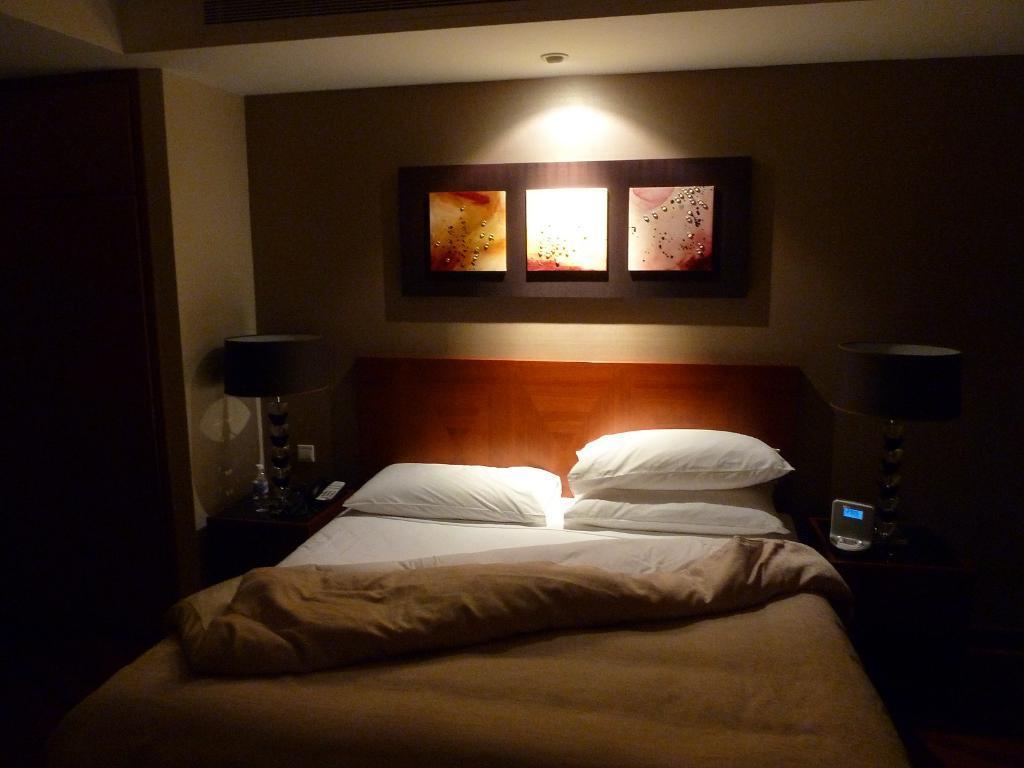Describe this image in one or two sentences. In the center we can see the bed on bed we can see bed sheet,three pillows. Back of bed there is a wall and beside the bed there is a table lamp. 